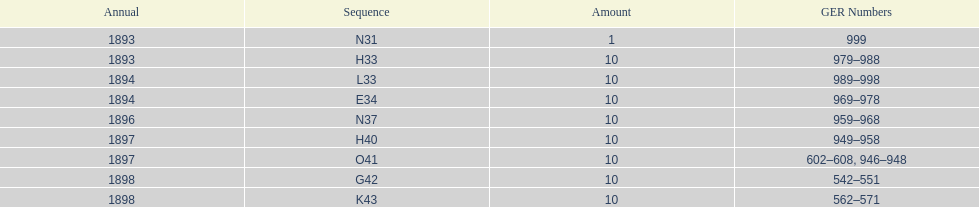Which had more ger numbers, 1898 or 1893? 1898. 